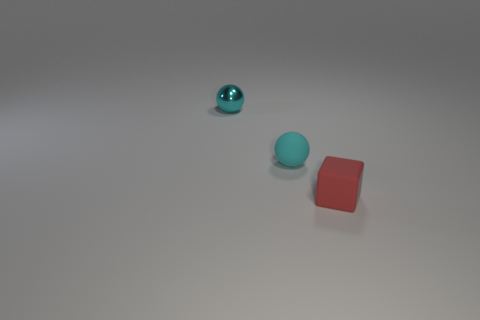Add 2 cylinders. How many objects exist? 5 Subtract all cubes. How many objects are left? 2 Add 1 tiny metal spheres. How many tiny metal spheres exist? 2 Subtract 0 green blocks. How many objects are left? 3 Subtract all purple spheres. Subtract all red things. How many objects are left? 2 Add 1 matte blocks. How many matte blocks are left? 2 